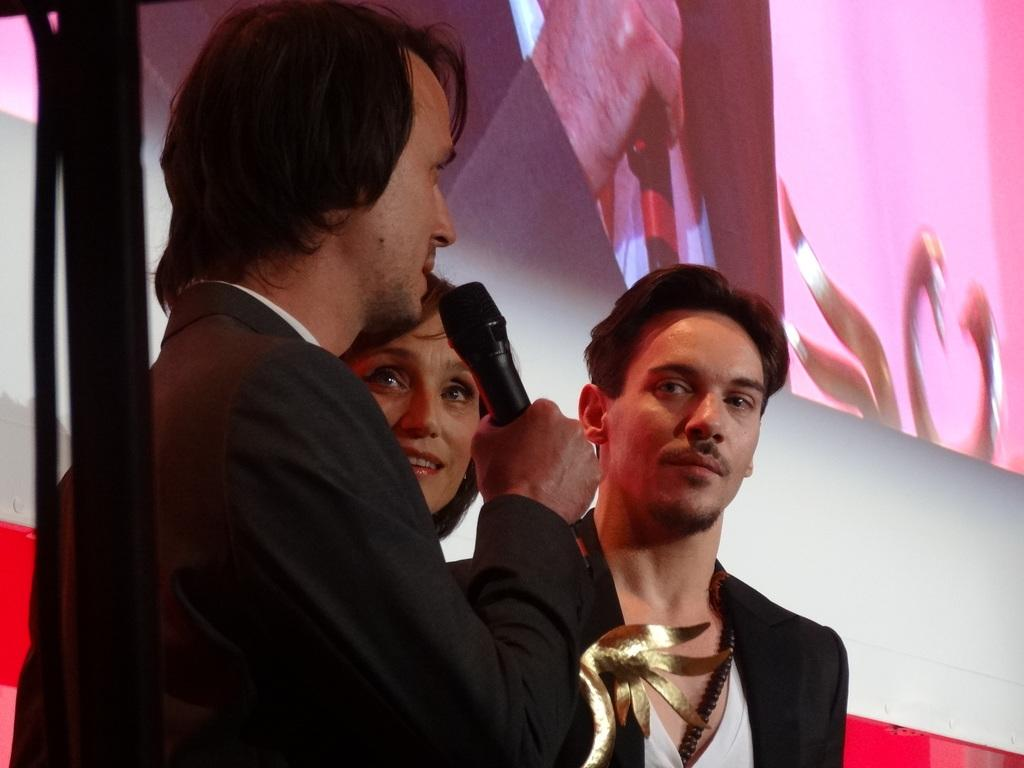What are the people in the image doing? The people in the image are standing, and one person is holding a mic while another person is holding an award. What are the people wearing? The people are wearing coats. What can be seen in the background of the image? There is a stand and a screen on the wall in the background. What type of leaf can be seen falling from the ceiling in the image? There is no leaf falling from the ceiling in the image. Can you tell me how many times the person holding the award turns around in the image? The person holding the award does not turn around in the image; they are standing still. 